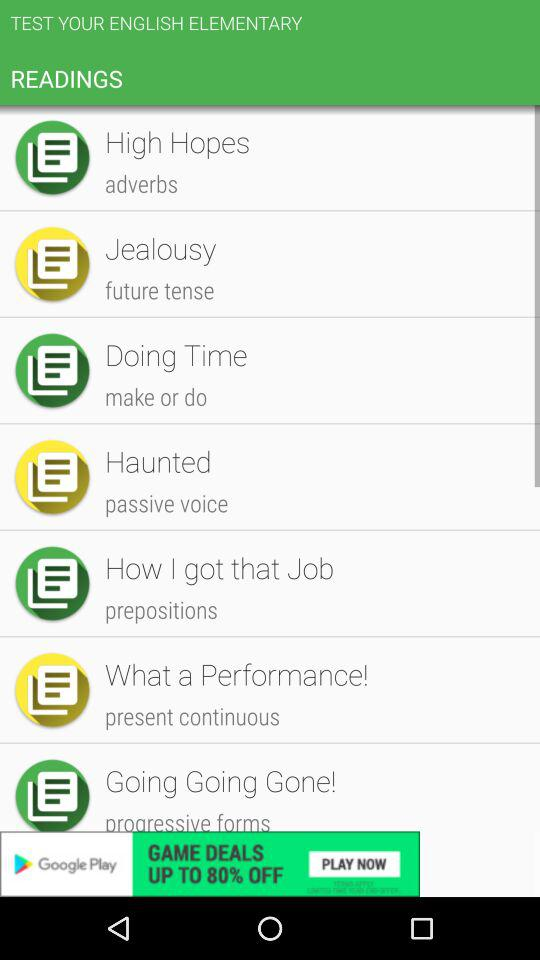What is the sentence written in "present continuous"? The sentence written is "What a Performance!". 